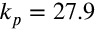Convert formula to latex. <formula><loc_0><loc_0><loc_500><loc_500>k _ { p } = 2 7 . 9</formula> 